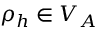<formula> <loc_0><loc_0><loc_500><loc_500>\rho _ { h } \in V _ { A }</formula> 